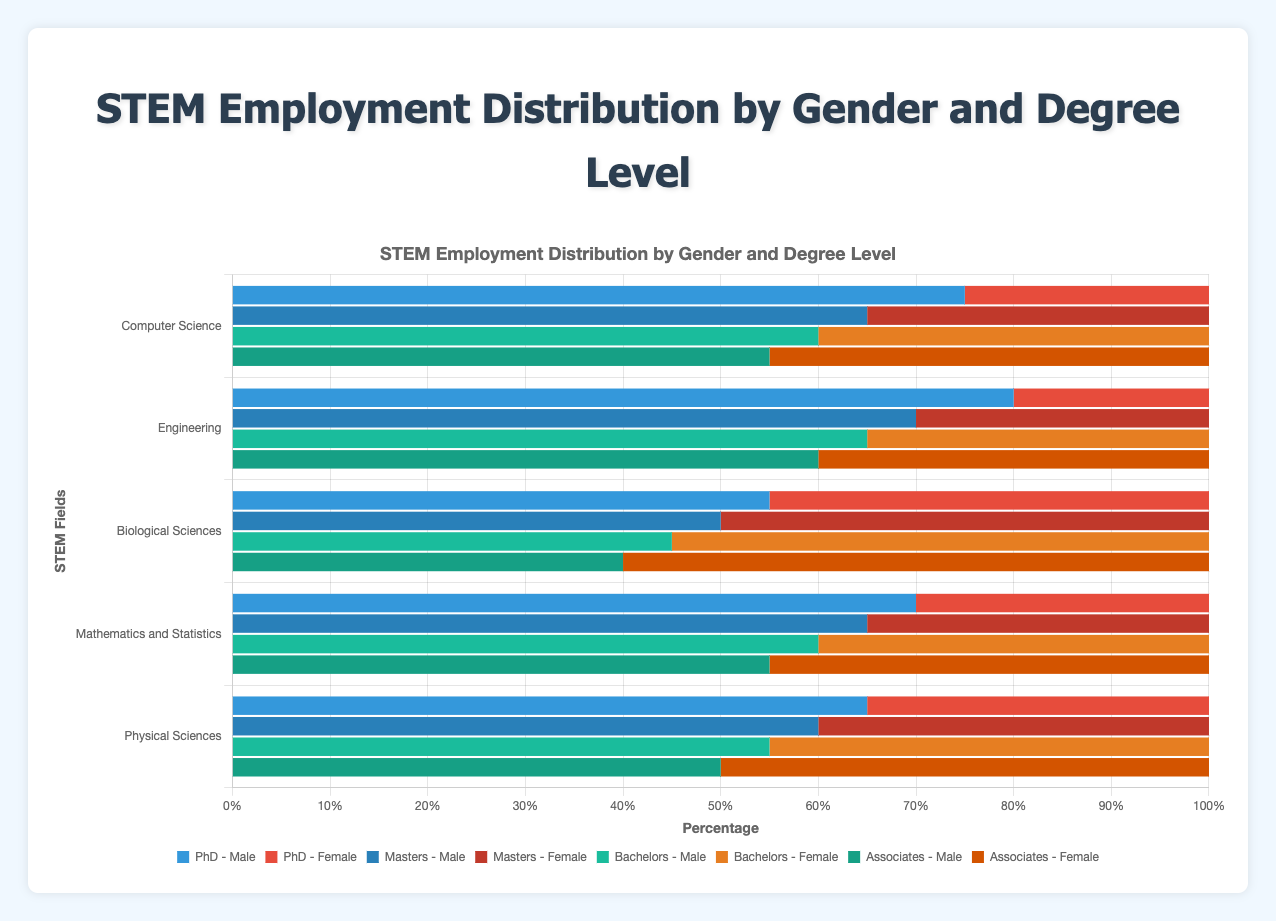What percentage of women in Biological Sciences have an Associates degree compared to those with a PhD? Women with an Associates degree in Biological Sciences is 60%, and those with a PhD is 45%. 60 is greater than 45, so a higher percentage of women have an Associates degree compared to a PhD in Biological Sciences.
Answer: More What is the total percentage of males in Computer Science who have PhDs and Masters degrees? Males with PhDs in Computer Science is 75%, and those with Masters degrees is 65%. Summing them up: 75 + 65 = 140.
Answer: 140% Which STEM field shows gender parity (equal representation) at the Masters degree level? Biological Sciences is the only field where the percentage of males and females with Masters degrees is equal at 50% each, representing gender parity.
Answer: Biological Sciences By how much is the percentage of males with PhDs higher in Engineering than in Biological Sciences? Percentage of males with PhDs in Engineering is 80%, and in Biological Sciences, it is 55%. The difference is 80 - 55 = 25.
Answer: 25% What field has the highest percentage of females with Bachelors degrees? The field with the highest percentage of females with Bachelors degrees is Biological Sciences at 55%.
Answer: Biological Sciences Which degree level in Mathematics and Statistics shows the smallest gender gap? The Associates degree level in Mathematics and Statistics has 55% males and 45% females, resulting in a gender gap of 10%. This is the smallest gap across the degree levels in this field.
Answer: Associates In which field is the percentage of males with Bachelors degrees the same as the percentage of females with Masters degrees? In Physical Sciences, 55% of males have Bachelors degrees, and in Biological Sciences, 50% of females have Masters degrees. The percentages aren't equal across any field compared.
Answer: None For which degree level is the percentage of males consistently above 60% in all STEM fields? For PhDs, the percentage of males is consistently above 60% in all fields: Computer Science (75%), Engineering (80%), Biological Sciences (55%, not consistent), Mathematics and Statistics (70%), Physical Sciences (65%).
Answer: None 